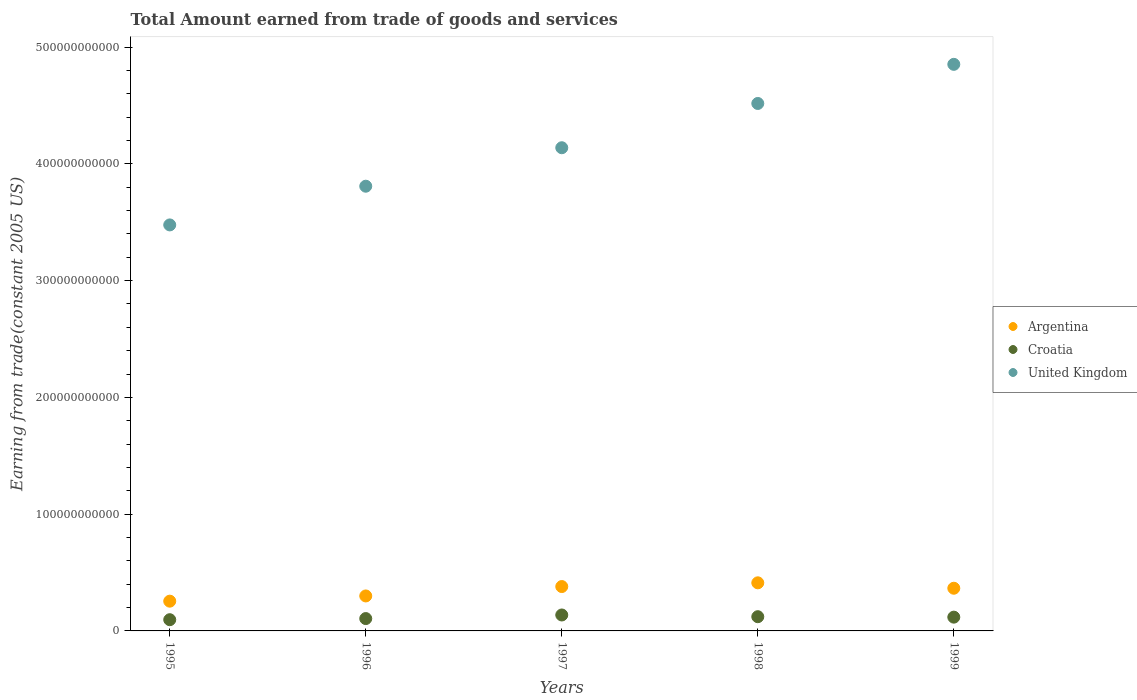What is the total amount earned by trading goods and services in Croatia in 1995?
Ensure brevity in your answer.  9.61e+09. Across all years, what is the maximum total amount earned by trading goods and services in Croatia?
Provide a succinct answer. 1.36e+1. Across all years, what is the minimum total amount earned by trading goods and services in Croatia?
Offer a terse response. 9.61e+09. What is the total total amount earned by trading goods and services in Argentina in the graph?
Your answer should be very brief. 1.71e+11. What is the difference between the total amount earned by trading goods and services in United Kingdom in 1996 and that in 1998?
Your answer should be compact. -7.09e+1. What is the difference between the total amount earned by trading goods and services in United Kingdom in 1998 and the total amount earned by trading goods and services in Argentina in 1995?
Provide a short and direct response. 4.26e+11. What is the average total amount earned by trading goods and services in United Kingdom per year?
Give a very brief answer. 4.16e+11. In the year 1995, what is the difference between the total amount earned by trading goods and services in Croatia and total amount earned by trading goods and services in Argentina?
Provide a succinct answer. -1.59e+1. In how many years, is the total amount earned by trading goods and services in Argentina greater than 320000000000 US$?
Provide a short and direct response. 0. What is the ratio of the total amount earned by trading goods and services in Croatia in 1997 to that in 1998?
Offer a terse response. 1.12. What is the difference between the highest and the second highest total amount earned by trading goods and services in Argentina?
Make the answer very short. 3.20e+09. What is the difference between the highest and the lowest total amount earned by trading goods and services in Argentina?
Keep it short and to the point. 1.57e+1. Is the sum of the total amount earned by trading goods and services in United Kingdom in 1998 and 1999 greater than the maximum total amount earned by trading goods and services in Argentina across all years?
Provide a short and direct response. Yes. How many years are there in the graph?
Provide a succinct answer. 5. What is the difference between two consecutive major ticks on the Y-axis?
Ensure brevity in your answer.  1.00e+11. Are the values on the major ticks of Y-axis written in scientific E-notation?
Your response must be concise. No. Does the graph contain any zero values?
Provide a short and direct response. No. Where does the legend appear in the graph?
Your response must be concise. Center right. What is the title of the graph?
Make the answer very short. Total Amount earned from trade of goods and services. Does "Trinidad and Tobago" appear as one of the legend labels in the graph?
Make the answer very short. No. What is the label or title of the Y-axis?
Provide a succinct answer. Earning from trade(constant 2005 US). What is the Earning from trade(constant 2005 US) in Argentina in 1995?
Make the answer very short. 2.55e+1. What is the Earning from trade(constant 2005 US) in Croatia in 1995?
Provide a succinct answer. 9.61e+09. What is the Earning from trade(constant 2005 US) of United Kingdom in 1995?
Your answer should be very brief. 3.48e+11. What is the Earning from trade(constant 2005 US) in Argentina in 1996?
Keep it short and to the point. 2.99e+1. What is the Earning from trade(constant 2005 US) in Croatia in 1996?
Provide a succinct answer. 1.06e+1. What is the Earning from trade(constant 2005 US) of United Kingdom in 1996?
Ensure brevity in your answer.  3.81e+11. What is the Earning from trade(constant 2005 US) of Argentina in 1997?
Your answer should be very brief. 3.80e+1. What is the Earning from trade(constant 2005 US) in Croatia in 1997?
Make the answer very short. 1.36e+1. What is the Earning from trade(constant 2005 US) in United Kingdom in 1997?
Provide a succinct answer. 4.14e+11. What is the Earning from trade(constant 2005 US) in Argentina in 1998?
Ensure brevity in your answer.  4.12e+1. What is the Earning from trade(constant 2005 US) of Croatia in 1998?
Offer a terse response. 1.22e+1. What is the Earning from trade(constant 2005 US) in United Kingdom in 1998?
Your answer should be very brief. 4.52e+11. What is the Earning from trade(constant 2005 US) in Argentina in 1999?
Make the answer very short. 3.66e+1. What is the Earning from trade(constant 2005 US) of Croatia in 1999?
Ensure brevity in your answer.  1.18e+1. What is the Earning from trade(constant 2005 US) in United Kingdom in 1999?
Offer a terse response. 4.85e+11. Across all years, what is the maximum Earning from trade(constant 2005 US) in Argentina?
Your answer should be compact. 4.12e+1. Across all years, what is the maximum Earning from trade(constant 2005 US) in Croatia?
Your answer should be compact. 1.36e+1. Across all years, what is the maximum Earning from trade(constant 2005 US) of United Kingdom?
Offer a terse response. 4.85e+11. Across all years, what is the minimum Earning from trade(constant 2005 US) in Argentina?
Provide a succinct answer. 2.55e+1. Across all years, what is the minimum Earning from trade(constant 2005 US) in Croatia?
Ensure brevity in your answer.  9.61e+09. Across all years, what is the minimum Earning from trade(constant 2005 US) in United Kingdom?
Keep it short and to the point. 3.48e+11. What is the total Earning from trade(constant 2005 US) in Argentina in the graph?
Provide a short and direct response. 1.71e+11. What is the total Earning from trade(constant 2005 US) of Croatia in the graph?
Ensure brevity in your answer.  5.78e+1. What is the total Earning from trade(constant 2005 US) of United Kingdom in the graph?
Offer a very short reply. 2.08e+12. What is the difference between the Earning from trade(constant 2005 US) of Argentina in 1995 and that in 1996?
Offer a very short reply. -4.47e+09. What is the difference between the Earning from trade(constant 2005 US) of Croatia in 1995 and that in 1996?
Your answer should be very brief. -9.67e+08. What is the difference between the Earning from trade(constant 2005 US) in United Kingdom in 1995 and that in 1996?
Your answer should be very brief. -3.31e+1. What is the difference between the Earning from trade(constant 2005 US) of Argentina in 1995 and that in 1997?
Your response must be concise. -1.25e+1. What is the difference between the Earning from trade(constant 2005 US) in Croatia in 1995 and that in 1997?
Offer a very short reply. -4.04e+09. What is the difference between the Earning from trade(constant 2005 US) in United Kingdom in 1995 and that in 1997?
Offer a very short reply. -6.61e+1. What is the difference between the Earning from trade(constant 2005 US) in Argentina in 1995 and that in 1998?
Provide a succinct answer. -1.57e+1. What is the difference between the Earning from trade(constant 2005 US) of Croatia in 1995 and that in 1998?
Offer a very short reply. -2.57e+09. What is the difference between the Earning from trade(constant 2005 US) of United Kingdom in 1995 and that in 1998?
Provide a succinct answer. -1.04e+11. What is the difference between the Earning from trade(constant 2005 US) in Argentina in 1995 and that in 1999?
Provide a short and direct response. -1.11e+1. What is the difference between the Earning from trade(constant 2005 US) in Croatia in 1995 and that in 1999?
Give a very brief answer. -2.18e+09. What is the difference between the Earning from trade(constant 2005 US) of United Kingdom in 1995 and that in 1999?
Your answer should be very brief. -1.38e+11. What is the difference between the Earning from trade(constant 2005 US) of Argentina in 1996 and that in 1997?
Your answer should be very brief. -8.05e+09. What is the difference between the Earning from trade(constant 2005 US) in Croatia in 1996 and that in 1997?
Give a very brief answer. -3.07e+09. What is the difference between the Earning from trade(constant 2005 US) in United Kingdom in 1996 and that in 1997?
Give a very brief answer. -3.29e+1. What is the difference between the Earning from trade(constant 2005 US) in Argentina in 1996 and that in 1998?
Ensure brevity in your answer.  -1.12e+1. What is the difference between the Earning from trade(constant 2005 US) of Croatia in 1996 and that in 1998?
Give a very brief answer. -1.60e+09. What is the difference between the Earning from trade(constant 2005 US) in United Kingdom in 1996 and that in 1998?
Provide a succinct answer. -7.09e+1. What is the difference between the Earning from trade(constant 2005 US) of Argentina in 1996 and that in 1999?
Provide a short and direct response. -6.60e+09. What is the difference between the Earning from trade(constant 2005 US) of Croatia in 1996 and that in 1999?
Make the answer very short. -1.22e+09. What is the difference between the Earning from trade(constant 2005 US) in United Kingdom in 1996 and that in 1999?
Keep it short and to the point. -1.04e+11. What is the difference between the Earning from trade(constant 2005 US) of Argentina in 1997 and that in 1998?
Keep it short and to the point. -3.20e+09. What is the difference between the Earning from trade(constant 2005 US) of Croatia in 1997 and that in 1998?
Make the answer very short. 1.47e+09. What is the difference between the Earning from trade(constant 2005 US) of United Kingdom in 1997 and that in 1998?
Make the answer very short. -3.79e+1. What is the difference between the Earning from trade(constant 2005 US) in Argentina in 1997 and that in 1999?
Your answer should be very brief. 1.44e+09. What is the difference between the Earning from trade(constant 2005 US) of Croatia in 1997 and that in 1999?
Offer a very short reply. 1.86e+09. What is the difference between the Earning from trade(constant 2005 US) in United Kingdom in 1997 and that in 1999?
Offer a terse response. -7.14e+1. What is the difference between the Earning from trade(constant 2005 US) in Argentina in 1998 and that in 1999?
Provide a succinct answer. 4.64e+09. What is the difference between the Earning from trade(constant 2005 US) of Croatia in 1998 and that in 1999?
Provide a succinct answer. 3.87e+08. What is the difference between the Earning from trade(constant 2005 US) in United Kingdom in 1998 and that in 1999?
Keep it short and to the point. -3.35e+1. What is the difference between the Earning from trade(constant 2005 US) of Argentina in 1995 and the Earning from trade(constant 2005 US) of Croatia in 1996?
Your answer should be very brief. 1.49e+1. What is the difference between the Earning from trade(constant 2005 US) of Argentina in 1995 and the Earning from trade(constant 2005 US) of United Kingdom in 1996?
Provide a succinct answer. -3.55e+11. What is the difference between the Earning from trade(constant 2005 US) of Croatia in 1995 and the Earning from trade(constant 2005 US) of United Kingdom in 1996?
Ensure brevity in your answer.  -3.71e+11. What is the difference between the Earning from trade(constant 2005 US) of Argentina in 1995 and the Earning from trade(constant 2005 US) of Croatia in 1997?
Your answer should be very brief. 1.18e+1. What is the difference between the Earning from trade(constant 2005 US) of Argentina in 1995 and the Earning from trade(constant 2005 US) of United Kingdom in 1997?
Keep it short and to the point. -3.88e+11. What is the difference between the Earning from trade(constant 2005 US) of Croatia in 1995 and the Earning from trade(constant 2005 US) of United Kingdom in 1997?
Your answer should be compact. -4.04e+11. What is the difference between the Earning from trade(constant 2005 US) in Argentina in 1995 and the Earning from trade(constant 2005 US) in Croatia in 1998?
Provide a short and direct response. 1.33e+1. What is the difference between the Earning from trade(constant 2005 US) in Argentina in 1995 and the Earning from trade(constant 2005 US) in United Kingdom in 1998?
Ensure brevity in your answer.  -4.26e+11. What is the difference between the Earning from trade(constant 2005 US) of Croatia in 1995 and the Earning from trade(constant 2005 US) of United Kingdom in 1998?
Keep it short and to the point. -4.42e+11. What is the difference between the Earning from trade(constant 2005 US) in Argentina in 1995 and the Earning from trade(constant 2005 US) in Croatia in 1999?
Offer a very short reply. 1.37e+1. What is the difference between the Earning from trade(constant 2005 US) in Argentina in 1995 and the Earning from trade(constant 2005 US) in United Kingdom in 1999?
Provide a short and direct response. -4.60e+11. What is the difference between the Earning from trade(constant 2005 US) of Croatia in 1995 and the Earning from trade(constant 2005 US) of United Kingdom in 1999?
Provide a short and direct response. -4.76e+11. What is the difference between the Earning from trade(constant 2005 US) of Argentina in 1996 and the Earning from trade(constant 2005 US) of Croatia in 1997?
Provide a short and direct response. 1.63e+1. What is the difference between the Earning from trade(constant 2005 US) of Argentina in 1996 and the Earning from trade(constant 2005 US) of United Kingdom in 1997?
Your answer should be compact. -3.84e+11. What is the difference between the Earning from trade(constant 2005 US) of Croatia in 1996 and the Earning from trade(constant 2005 US) of United Kingdom in 1997?
Offer a very short reply. -4.03e+11. What is the difference between the Earning from trade(constant 2005 US) of Argentina in 1996 and the Earning from trade(constant 2005 US) of Croatia in 1998?
Provide a succinct answer. 1.78e+1. What is the difference between the Earning from trade(constant 2005 US) of Argentina in 1996 and the Earning from trade(constant 2005 US) of United Kingdom in 1998?
Give a very brief answer. -4.22e+11. What is the difference between the Earning from trade(constant 2005 US) of Croatia in 1996 and the Earning from trade(constant 2005 US) of United Kingdom in 1998?
Offer a very short reply. -4.41e+11. What is the difference between the Earning from trade(constant 2005 US) in Argentina in 1996 and the Earning from trade(constant 2005 US) in Croatia in 1999?
Offer a terse response. 1.82e+1. What is the difference between the Earning from trade(constant 2005 US) of Argentina in 1996 and the Earning from trade(constant 2005 US) of United Kingdom in 1999?
Offer a very short reply. -4.55e+11. What is the difference between the Earning from trade(constant 2005 US) of Croatia in 1996 and the Earning from trade(constant 2005 US) of United Kingdom in 1999?
Your answer should be very brief. -4.75e+11. What is the difference between the Earning from trade(constant 2005 US) in Argentina in 1997 and the Earning from trade(constant 2005 US) in Croatia in 1998?
Your answer should be compact. 2.58e+1. What is the difference between the Earning from trade(constant 2005 US) of Argentina in 1997 and the Earning from trade(constant 2005 US) of United Kingdom in 1998?
Keep it short and to the point. -4.14e+11. What is the difference between the Earning from trade(constant 2005 US) of Croatia in 1997 and the Earning from trade(constant 2005 US) of United Kingdom in 1998?
Your response must be concise. -4.38e+11. What is the difference between the Earning from trade(constant 2005 US) in Argentina in 1997 and the Earning from trade(constant 2005 US) in Croatia in 1999?
Keep it short and to the point. 2.62e+1. What is the difference between the Earning from trade(constant 2005 US) in Argentina in 1997 and the Earning from trade(constant 2005 US) in United Kingdom in 1999?
Offer a terse response. -4.47e+11. What is the difference between the Earning from trade(constant 2005 US) in Croatia in 1997 and the Earning from trade(constant 2005 US) in United Kingdom in 1999?
Provide a succinct answer. -4.72e+11. What is the difference between the Earning from trade(constant 2005 US) of Argentina in 1998 and the Earning from trade(constant 2005 US) of Croatia in 1999?
Give a very brief answer. 2.94e+1. What is the difference between the Earning from trade(constant 2005 US) of Argentina in 1998 and the Earning from trade(constant 2005 US) of United Kingdom in 1999?
Your response must be concise. -4.44e+11. What is the difference between the Earning from trade(constant 2005 US) of Croatia in 1998 and the Earning from trade(constant 2005 US) of United Kingdom in 1999?
Your response must be concise. -4.73e+11. What is the average Earning from trade(constant 2005 US) in Argentina per year?
Your answer should be very brief. 3.42e+1. What is the average Earning from trade(constant 2005 US) in Croatia per year?
Your response must be concise. 1.16e+1. What is the average Earning from trade(constant 2005 US) of United Kingdom per year?
Offer a very short reply. 4.16e+11. In the year 1995, what is the difference between the Earning from trade(constant 2005 US) of Argentina and Earning from trade(constant 2005 US) of Croatia?
Ensure brevity in your answer.  1.59e+1. In the year 1995, what is the difference between the Earning from trade(constant 2005 US) in Argentina and Earning from trade(constant 2005 US) in United Kingdom?
Offer a very short reply. -3.22e+11. In the year 1995, what is the difference between the Earning from trade(constant 2005 US) in Croatia and Earning from trade(constant 2005 US) in United Kingdom?
Provide a succinct answer. -3.38e+11. In the year 1996, what is the difference between the Earning from trade(constant 2005 US) of Argentina and Earning from trade(constant 2005 US) of Croatia?
Make the answer very short. 1.94e+1. In the year 1996, what is the difference between the Earning from trade(constant 2005 US) of Argentina and Earning from trade(constant 2005 US) of United Kingdom?
Your answer should be compact. -3.51e+11. In the year 1996, what is the difference between the Earning from trade(constant 2005 US) in Croatia and Earning from trade(constant 2005 US) in United Kingdom?
Your response must be concise. -3.70e+11. In the year 1997, what is the difference between the Earning from trade(constant 2005 US) in Argentina and Earning from trade(constant 2005 US) in Croatia?
Provide a short and direct response. 2.43e+1. In the year 1997, what is the difference between the Earning from trade(constant 2005 US) of Argentina and Earning from trade(constant 2005 US) of United Kingdom?
Make the answer very short. -3.76e+11. In the year 1997, what is the difference between the Earning from trade(constant 2005 US) of Croatia and Earning from trade(constant 2005 US) of United Kingdom?
Provide a short and direct response. -4.00e+11. In the year 1998, what is the difference between the Earning from trade(constant 2005 US) in Argentina and Earning from trade(constant 2005 US) in Croatia?
Provide a short and direct response. 2.90e+1. In the year 1998, what is the difference between the Earning from trade(constant 2005 US) in Argentina and Earning from trade(constant 2005 US) in United Kingdom?
Your answer should be very brief. -4.10e+11. In the year 1998, what is the difference between the Earning from trade(constant 2005 US) of Croatia and Earning from trade(constant 2005 US) of United Kingdom?
Make the answer very short. -4.40e+11. In the year 1999, what is the difference between the Earning from trade(constant 2005 US) of Argentina and Earning from trade(constant 2005 US) of Croatia?
Make the answer very short. 2.48e+1. In the year 1999, what is the difference between the Earning from trade(constant 2005 US) of Argentina and Earning from trade(constant 2005 US) of United Kingdom?
Your answer should be compact. -4.49e+11. In the year 1999, what is the difference between the Earning from trade(constant 2005 US) of Croatia and Earning from trade(constant 2005 US) of United Kingdom?
Make the answer very short. -4.73e+11. What is the ratio of the Earning from trade(constant 2005 US) in Argentina in 1995 to that in 1996?
Provide a short and direct response. 0.85. What is the ratio of the Earning from trade(constant 2005 US) in Croatia in 1995 to that in 1996?
Make the answer very short. 0.91. What is the ratio of the Earning from trade(constant 2005 US) in Argentina in 1995 to that in 1997?
Your answer should be compact. 0.67. What is the ratio of the Earning from trade(constant 2005 US) of Croatia in 1995 to that in 1997?
Offer a very short reply. 0.7. What is the ratio of the Earning from trade(constant 2005 US) in United Kingdom in 1995 to that in 1997?
Ensure brevity in your answer.  0.84. What is the ratio of the Earning from trade(constant 2005 US) in Argentina in 1995 to that in 1998?
Your response must be concise. 0.62. What is the ratio of the Earning from trade(constant 2005 US) in Croatia in 1995 to that in 1998?
Ensure brevity in your answer.  0.79. What is the ratio of the Earning from trade(constant 2005 US) of United Kingdom in 1995 to that in 1998?
Make the answer very short. 0.77. What is the ratio of the Earning from trade(constant 2005 US) of Argentina in 1995 to that in 1999?
Provide a succinct answer. 0.7. What is the ratio of the Earning from trade(constant 2005 US) in Croatia in 1995 to that in 1999?
Your answer should be compact. 0.81. What is the ratio of the Earning from trade(constant 2005 US) of United Kingdom in 1995 to that in 1999?
Your answer should be compact. 0.72. What is the ratio of the Earning from trade(constant 2005 US) of Argentina in 1996 to that in 1997?
Your answer should be compact. 0.79. What is the ratio of the Earning from trade(constant 2005 US) of Croatia in 1996 to that in 1997?
Keep it short and to the point. 0.77. What is the ratio of the Earning from trade(constant 2005 US) of United Kingdom in 1996 to that in 1997?
Provide a succinct answer. 0.92. What is the ratio of the Earning from trade(constant 2005 US) of Argentina in 1996 to that in 1998?
Your response must be concise. 0.73. What is the ratio of the Earning from trade(constant 2005 US) of Croatia in 1996 to that in 1998?
Provide a short and direct response. 0.87. What is the ratio of the Earning from trade(constant 2005 US) of United Kingdom in 1996 to that in 1998?
Provide a short and direct response. 0.84. What is the ratio of the Earning from trade(constant 2005 US) of Argentina in 1996 to that in 1999?
Make the answer very short. 0.82. What is the ratio of the Earning from trade(constant 2005 US) of Croatia in 1996 to that in 1999?
Provide a succinct answer. 0.9. What is the ratio of the Earning from trade(constant 2005 US) of United Kingdom in 1996 to that in 1999?
Your answer should be compact. 0.78. What is the ratio of the Earning from trade(constant 2005 US) of Argentina in 1997 to that in 1998?
Your answer should be very brief. 0.92. What is the ratio of the Earning from trade(constant 2005 US) of Croatia in 1997 to that in 1998?
Keep it short and to the point. 1.12. What is the ratio of the Earning from trade(constant 2005 US) in United Kingdom in 1997 to that in 1998?
Provide a succinct answer. 0.92. What is the ratio of the Earning from trade(constant 2005 US) of Argentina in 1997 to that in 1999?
Provide a succinct answer. 1.04. What is the ratio of the Earning from trade(constant 2005 US) of Croatia in 1997 to that in 1999?
Your answer should be very brief. 1.16. What is the ratio of the Earning from trade(constant 2005 US) in United Kingdom in 1997 to that in 1999?
Your answer should be very brief. 0.85. What is the ratio of the Earning from trade(constant 2005 US) of Argentina in 1998 to that in 1999?
Offer a terse response. 1.13. What is the ratio of the Earning from trade(constant 2005 US) of Croatia in 1998 to that in 1999?
Provide a short and direct response. 1.03. What is the ratio of the Earning from trade(constant 2005 US) of United Kingdom in 1998 to that in 1999?
Your answer should be very brief. 0.93. What is the difference between the highest and the second highest Earning from trade(constant 2005 US) of Argentina?
Your answer should be very brief. 3.20e+09. What is the difference between the highest and the second highest Earning from trade(constant 2005 US) in Croatia?
Keep it short and to the point. 1.47e+09. What is the difference between the highest and the second highest Earning from trade(constant 2005 US) of United Kingdom?
Give a very brief answer. 3.35e+1. What is the difference between the highest and the lowest Earning from trade(constant 2005 US) of Argentina?
Offer a terse response. 1.57e+1. What is the difference between the highest and the lowest Earning from trade(constant 2005 US) in Croatia?
Ensure brevity in your answer.  4.04e+09. What is the difference between the highest and the lowest Earning from trade(constant 2005 US) in United Kingdom?
Your response must be concise. 1.38e+11. 